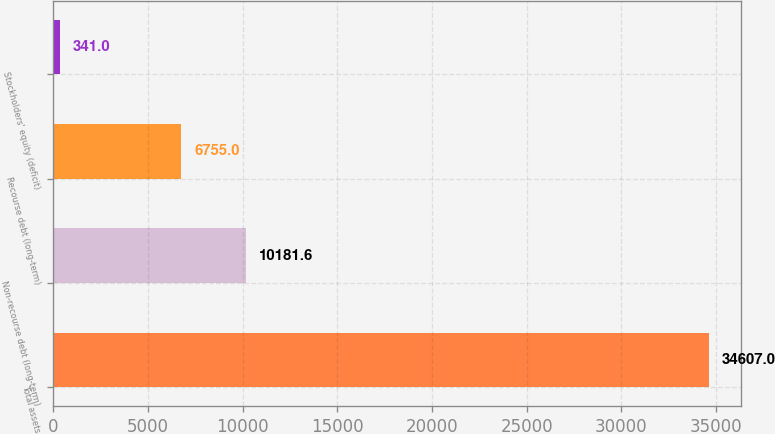Convert chart. <chart><loc_0><loc_0><loc_500><loc_500><bar_chart><fcel>Total assets<fcel>Non-recourse debt (long-term)<fcel>Recourse debt (long-term)<fcel>Stockholders' equity (deficit)<nl><fcel>34607<fcel>10181.6<fcel>6755<fcel>341<nl></chart> 